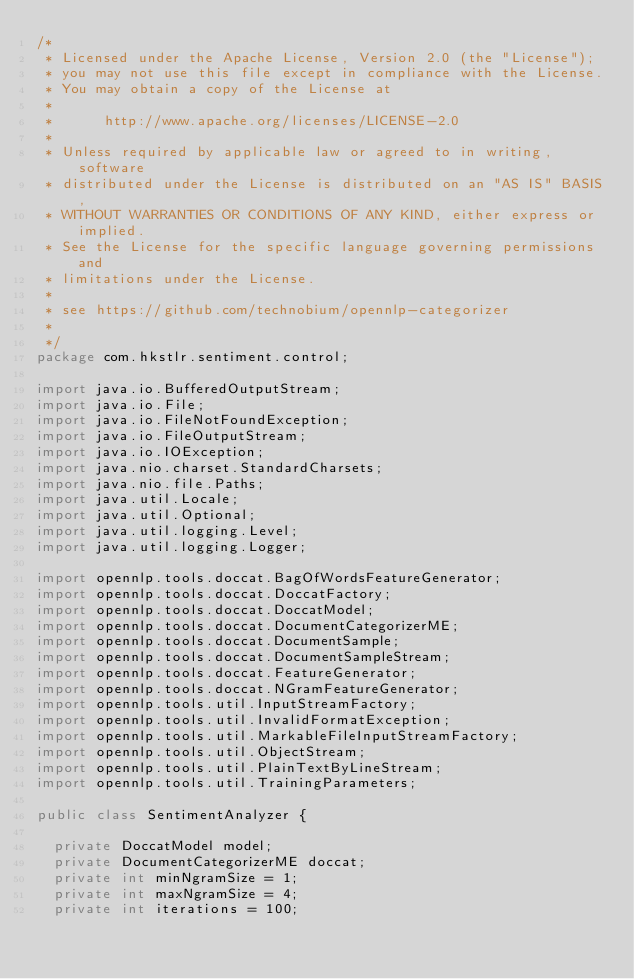Convert code to text. <code><loc_0><loc_0><loc_500><loc_500><_Java_>/*
 * Licensed under the Apache License, Version 2.0 (the "License");
 * you may not use this file except in compliance with the License.
 * You may obtain a copy of the License at
 *
 *      http://www.apache.org/licenses/LICENSE-2.0
 *
 * Unless required by applicable law or agreed to in writing, software
 * distributed under the License is distributed on an "AS IS" BASIS,
 * WITHOUT WARRANTIES OR CONDITIONS OF ANY KIND, either express or implied.
 * See the License for the specific language governing permissions and
 * limitations under the License.
 * 
 * see https://github.com/technobium/opennlp-categorizer
 * 
 */
package com.hkstlr.sentiment.control;

import java.io.BufferedOutputStream;
import java.io.File;
import java.io.FileNotFoundException;
import java.io.FileOutputStream;
import java.io.IOException;
import java.nio.charset.StandardCharsets;
import java.nio.file.Paths;
import java.util.Locale;
import java.util.Optional;
import java.util.logging.Level;
import java.util.logging.Logger;

import opennlp.tools.doccat.BagOfWordsFeatureGenerator;
import opennlp.tools.doccat.DoccatFactory;
import opennlp.tools.doccat.DoccatModel;
import opennlp.tools.doccat.DocumentCategorizerME;
import opennlp.tools.doccat.DocumentSample;
import opennlp.tools.doccat.DocumentSampleStream;
import opennlp.tools.doccat.FeatureGenerator;
import opennlp.tools.doccat.NGramFeatureGenerator;
import opennlp.tools.util.InputStreamFactory;
import opennlp.tools.util.InvalidFormatException;
import opennlp.tools.util.MarkableFileInputStreamFactory;
import opennlp.tools.util.ObjectStream;
import opennlp.tools.util.PlainTextByLineStream;
import opennlp.tools.util.TrainingParameters;

public class SentimentAnalyzer {

	private DoccatModel model;
	private DocumentCategorizerME doccat;
	private int minNgramSize = 1;
	private int maxNgramSize = 4;
	private int iterations = 100;</code> 